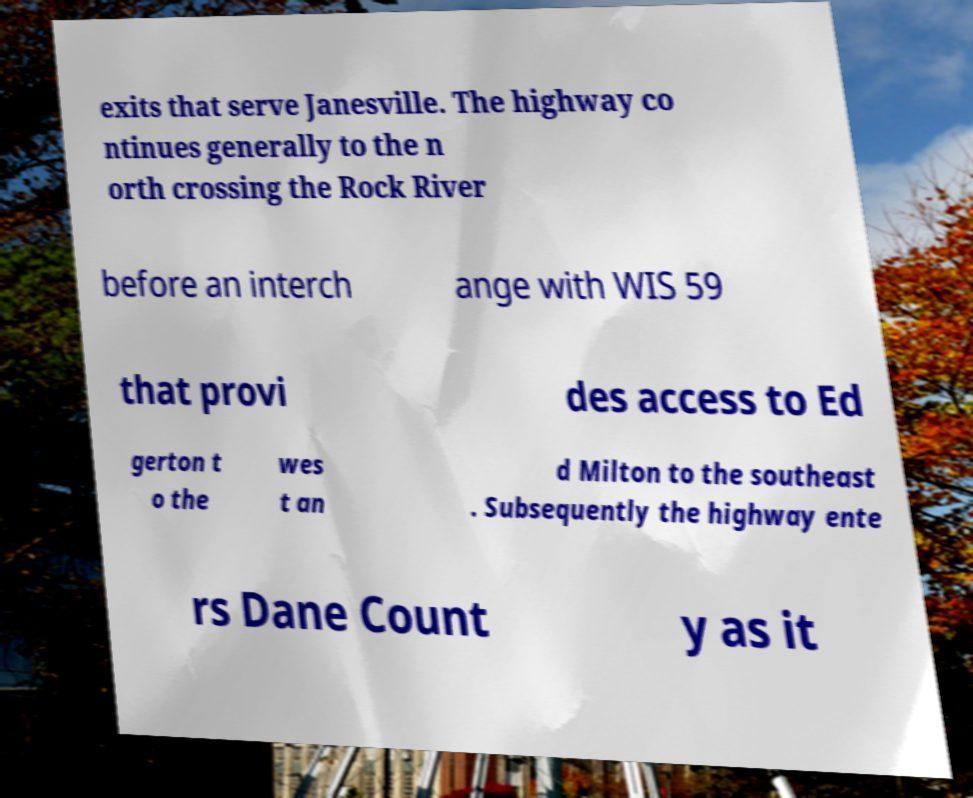What messages or text are displayed in this image? I need them in a readable, typed format. exits that serve Janesville. The highway co ntinues generally to the n orth crossing the Rock River before an interch ange with WIS 59 that provi des access to Ed gerton t o the wes t an d Milton to the southeast . Subsequently the highway ente rs Dane Count y as it 